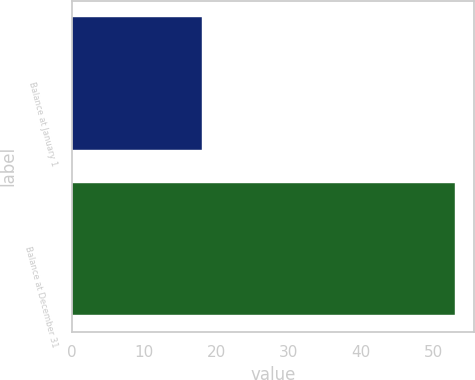<chart> <loc_0><loc_0><loc_500><loc_500><bar_chart><fcel>Balance at January 1<fcel>Balance at December 31<nl><fcel>18<fcel>53<nl></chart> 